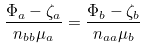<formula> <loc_0><loc_0><loc_500><loc_500>\frac { \Phi _ { a } - \zeta _ { a } } { n _ { b b } \mu _ { a } } = \frac { \Phi _ { b } - \zeta _ { b } } { n _ { a a } \mu _ { b } }</formula> 